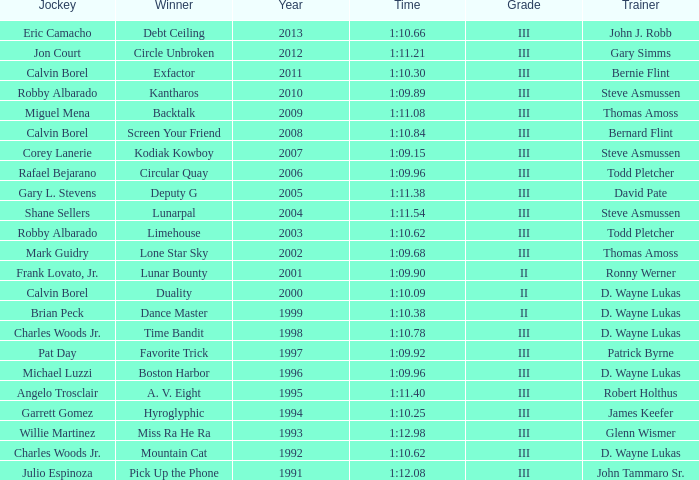Which trainer won the hyroglyphic in a year that was before 2010? James Keefer. 